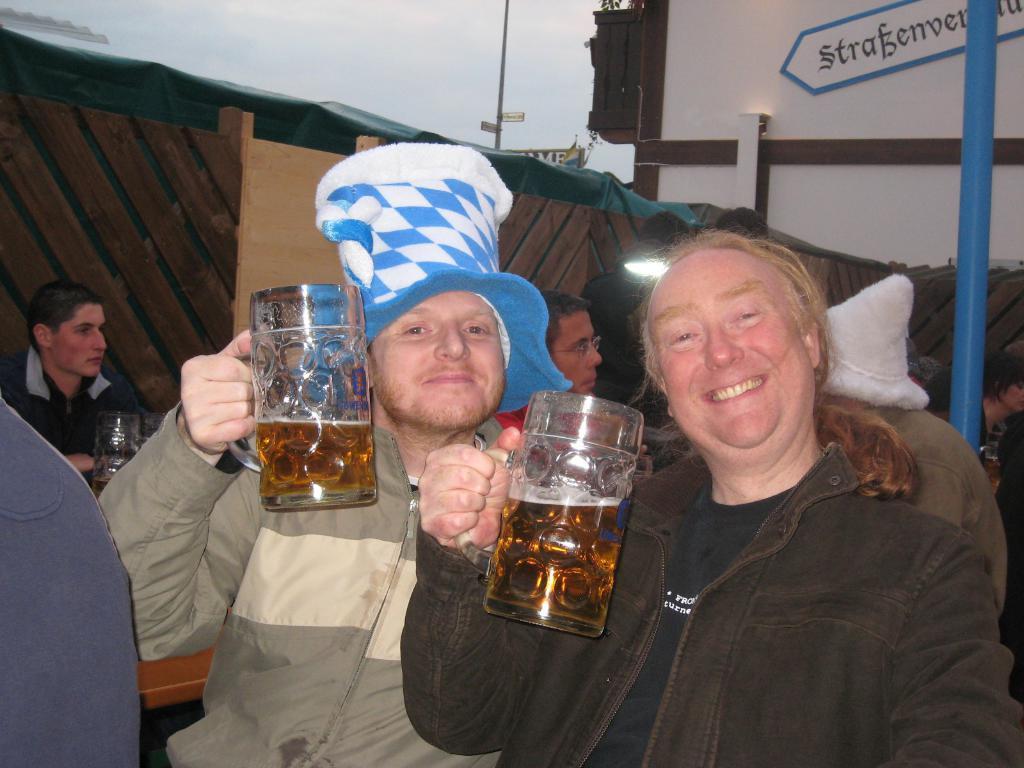Please provide a concise description of this image. In this image I can see number of people where two of them are holding jars, I can also see he is wearing a hat and also I can see smile on their faces. In the background I can see one more jar. 